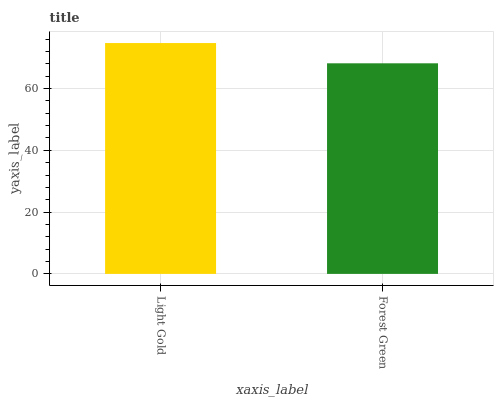Is Forest Green the minimum?
Answer yes or no. Yes. Is Light Gold the maximum?
Answer yes or no. Yes. Is Forest Green the maximum?
Answer yes or no. No. Is Light Gold greater than Forest Green?
Answer yes or no. Yes. Is Forest Green less than Light Gold?
Answer yes or no. Yes. Is Forest Green greater than Light Gold?
Answer yes or no. No. Is Light Gold less than Forest Green?
Answer yes or no. No. Is Light Gold the high median?
Answer yes or no. Yes. Is Forest Green the low median?
Answer yes or no. Yes. Is Forest Green the high median?
Answer yes or no. No. Is Light Gold the low median?
Answer yes or no. No. 